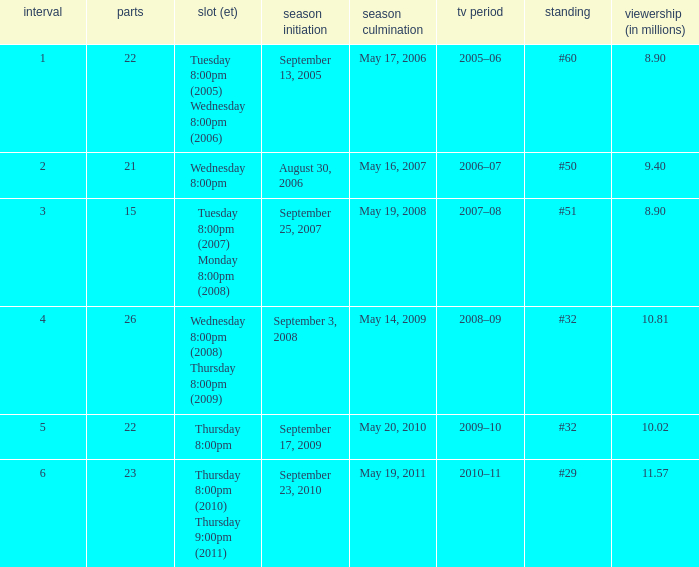What tv season was episode 23 broadcast? 2010–11. 